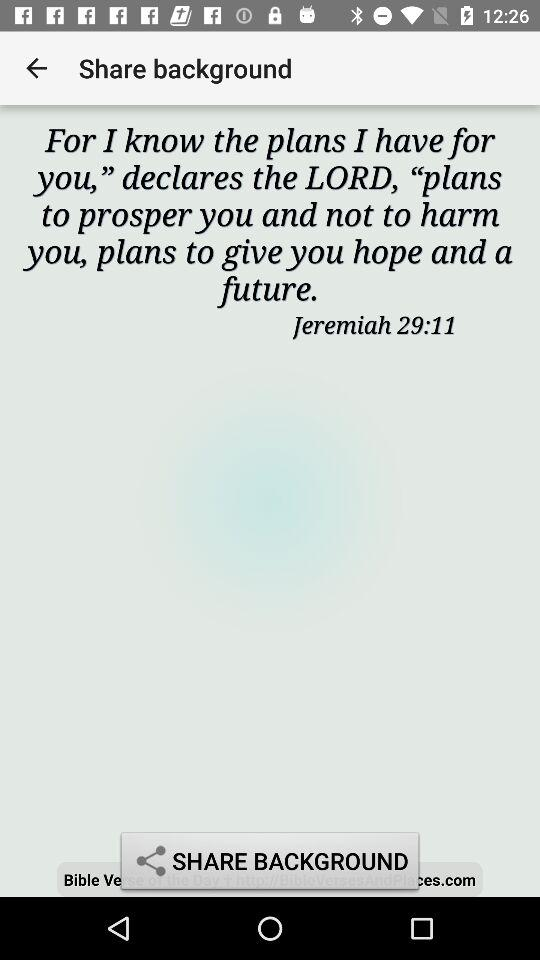What is the time?
When the provided information is insufficient, respond with <no answer>. <no answer> 